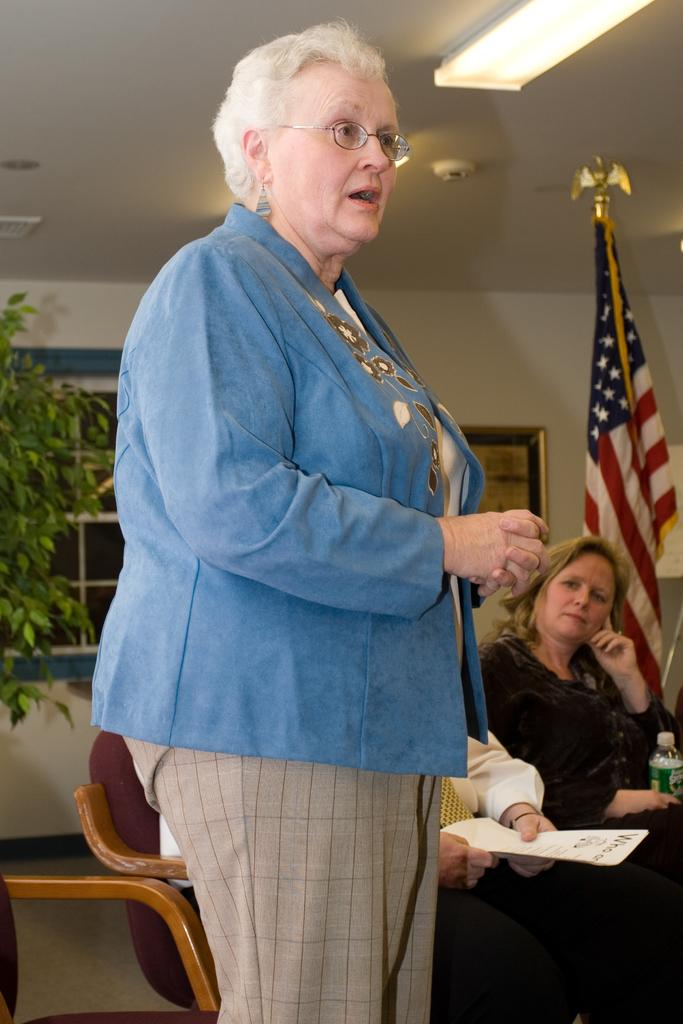Who is present in the image? There is a woman in the image. What is the woman doing? The woman is talking. What can be seen on the right side of the image? There is a flag on the right side of the image. What is on the left side of the image? There is a plant on the left side of the image. Who else is present in the image besides the woman? There is a man and a woman sitting beside the woman on chairs. What type of metal is the woman using to communicate her sense of invention in the image? There is no mention of metal or invention in the image; the woman is simply talking. 